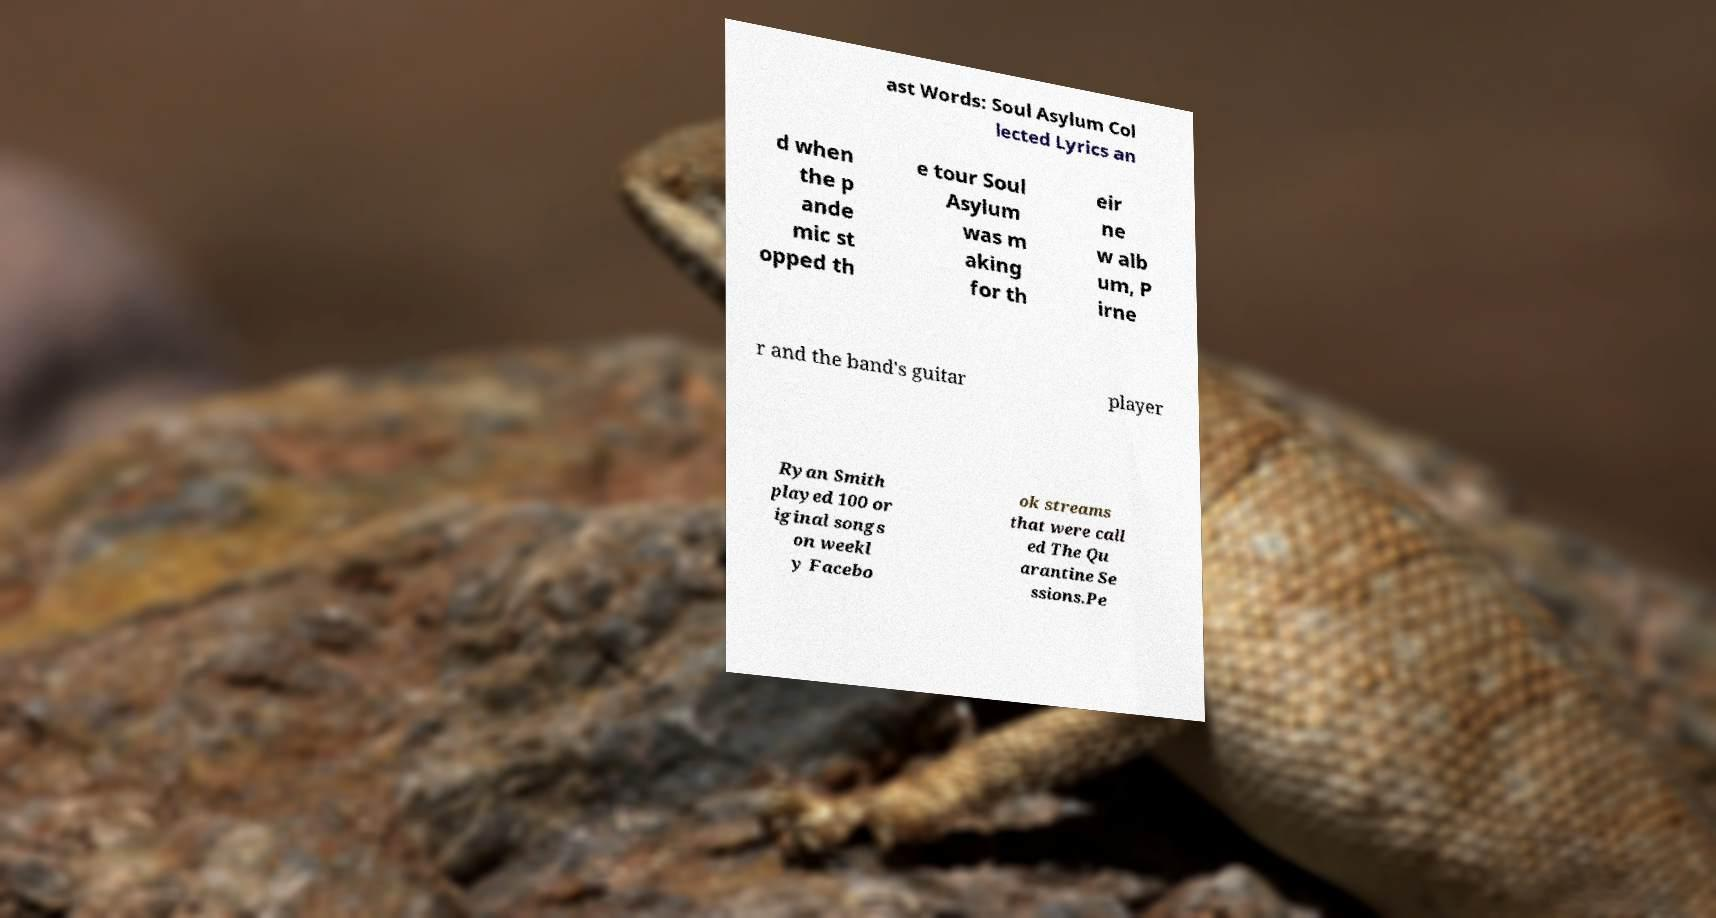Please read and relay the text visible in this image. What does it say? ast Words: Soul Asylum Col lected Lyrics an d when the p ande mic st opped th e tour Soul Asylum was m aking for th eir ne w alb um, P irne r and the band's guitar player Ryan Smith played 100 or iginal songs on weekl y Facebo ok streams that were call ed The Qu arantine Se ssions.Pe 